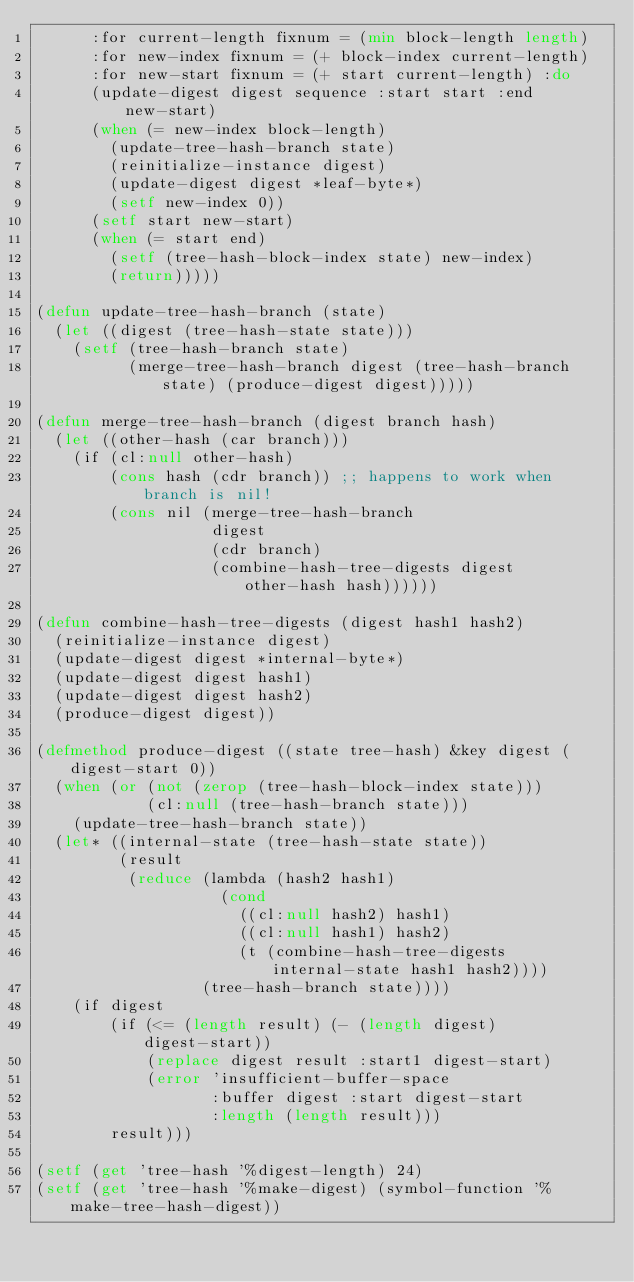<code> <loc_0><loc_0><loc_500><loc_500><_Lisp_>      :for current-length fixnum = (min block-length length)
      :for new-index fixnum = (+ block-index current-length)
      :for new-start fixnum = (+ start current-length) :do
      (update-digest digest sequence :start start :end new-start)
      (when (= new-index block-length)
        (update-tree-hash-branch state)
        (reinitialize-instance digest)
        (update-digest digest *leaf-byte*)
        (setf new-index 0))
      (setf start new-start)
      (when (= start end)
        (setf (tree-hash-block-index state) new-index)
        (return)))))

(defun update-tree-hash-branch (state)
  (let ((digest (tree-hash-state state)))
    (setf (tree-hash-branch state)
          (merge-tree-hash-branch digest (tree-hash-branch state) (produce-digest digest)))))

(defun merge-tree-hash-branch (digest branch hash)
  (let ((other-hash (car branch)))
    (if (cl:null other-hash)
        (cons hash (cdr branch)) ;; happens to work when branch is nil!
        (cons nil (merge-tree-hash-branch
                   digest
                   (cdr branch)
                   (combine-hash-tree-digests digest other-hash hash))))))

(defun combine-hash-tree-digests (digest hash1 hash2)
  (reinitialize-instance digest)
  (update-digest digest *internal-byte*)
  (update-digest digest hash1)
  (update-digest digest hash2)
  (produce-digest digest))

(defmethod produce-digest ((state tree-hash) &key digest (digest-start 0))
  (when (or (not (zerop (tree-hash-block-index state)))
            (cl:null (tree-hash-branch state)))
    (update-tree-hash-branch state))
  (let* ((internal-state (tree-hash-state state))
         (result
          (reduce (lambda (hash2 hash1)
                    (cond
                      ((cl:null hash2) hash1)
                      ((cl:null hash1) hash2)
                      (t (combine-hash-tree-digests internal-state hash1 hash2))))
                  (tree-hash-branch state))))
    (if digest
        (if (<= (length result) (- (length digest) digest-start))
            (replace digest result :start1 digest-start)
            (error 'insufficient-buffer-space
                   :buffer digest :start digest-start
                   :length (length result)))
        result)))

(setf (get 'tree-hash '%digest-length) 24)
(setf (get 'tree-hash '%make-digest) (symbol-function '%make-tree-hash-digest))
</code> 